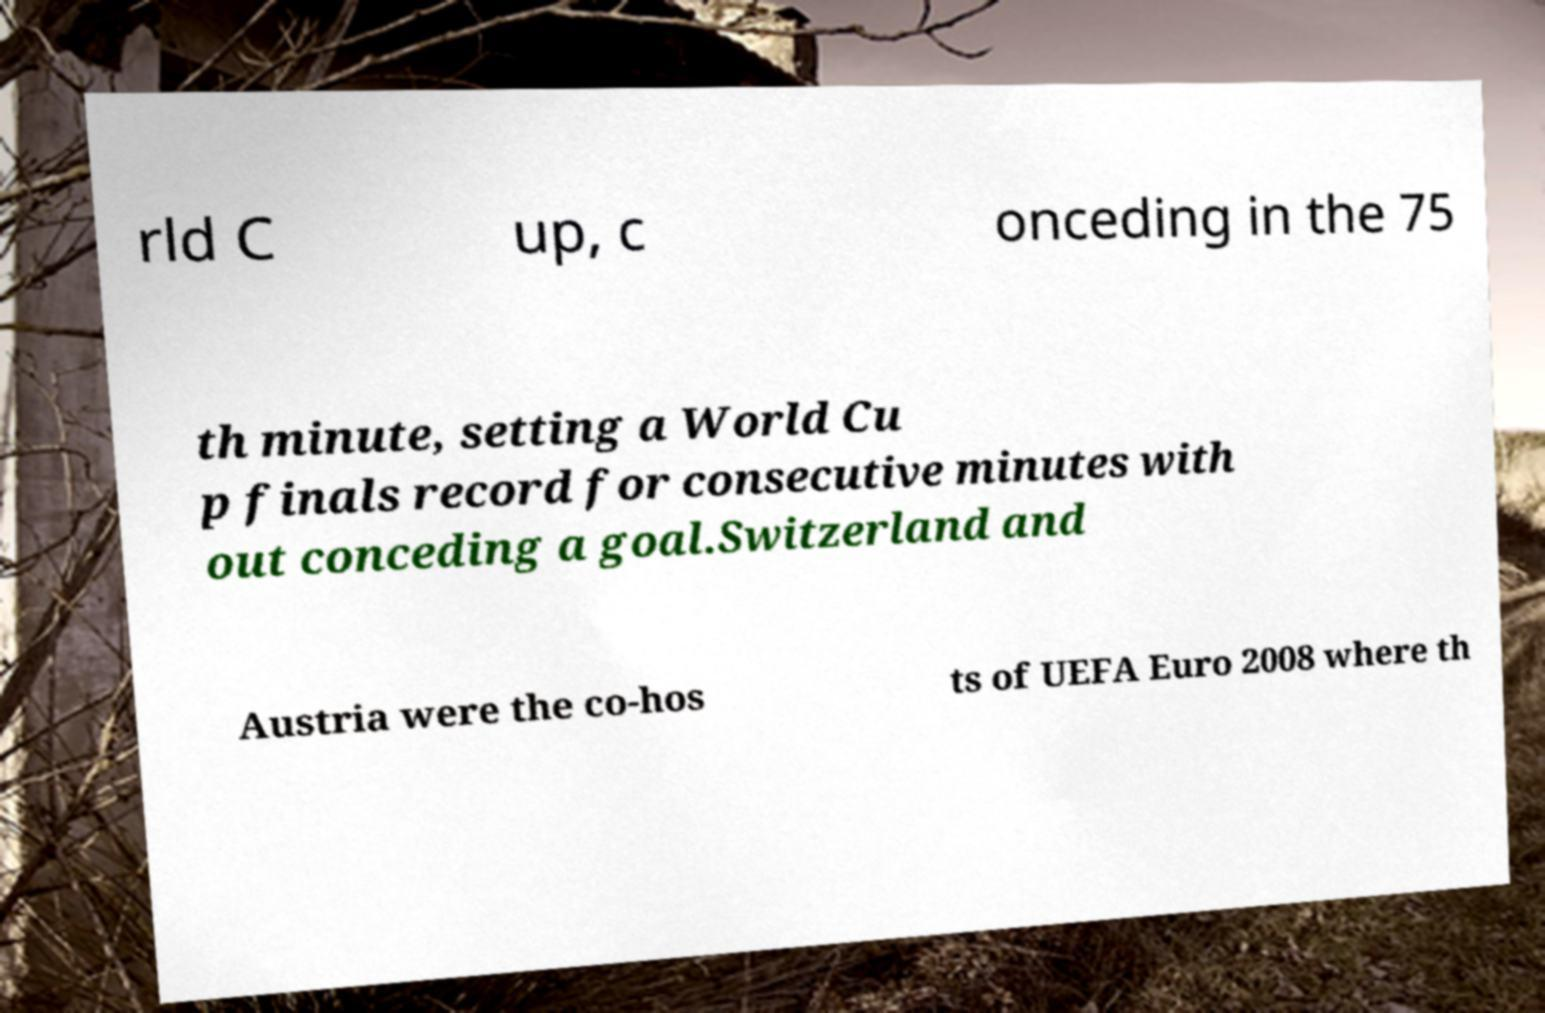Can you accurately transcribe the text from the provided image for me? rld C up, c onceding in the 75 th minute, setting a World Cu p finals record for consecutive minutes with out conceding a goal.Switzerland and Austria were the co-hos ts of UEFA Euro 2008 where th 